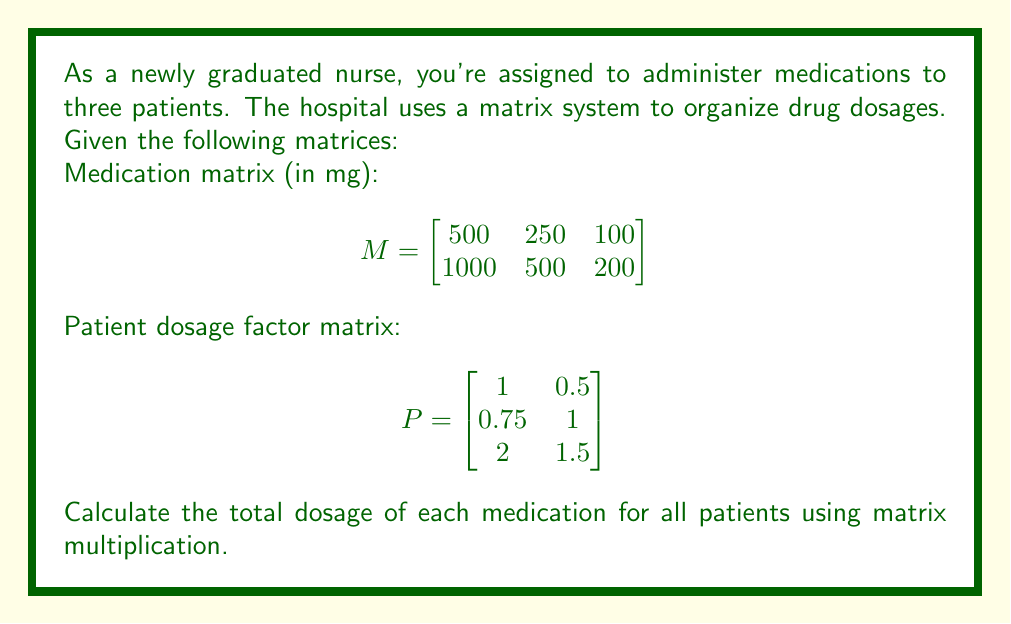Give your solution to this math problem. To solve this problem, we need to multiply the medication matrix (M) by the patient dosage factor matrix (P). The resulting matrix will give us the total dosage of each medication for all patients.

Step 1: Set up the matrix multiplication
$$M \times P = \begin{bmatrix}
500 & 250 & 100 \\
1000 & 500 & 200
\end{bmatrix} \times \begin{bmatrix}
1 & 0.5 \\
0.75 & 1 \\
2 & 1.5
\end{bmatrix}$$

Step 2: Perform the matrix multiplication
For each element in the resulting matrix, we multiply the corresponding row of M with the corresponding column of P and sum the results.

Element (1,1):
$(500 \times 1) + (250 \times 0.75) + (100 \times 2) = 500 + 187.5 + 200 = 887.5$

Element (1,2):
$(500 \times 0.5) + (250 \times 1) + (100 \times 1.5) = 250 + 250 + 150 = 650$

Element (2,1):
$(1000 \times 1) + (500 \times 0.75) + (200 \times 2) = 1000 + 375 + 400 = 1775$

Element (2,2):
$(1000 \times 0.5) + (500 \times 1) + (200 \times 1.5) = 500 + 500 + 300 = 1300$

Step 3: Write the resulting matrix
$$\begin{bmatrix}
887.5 & 650 \\
1775 & 1300
\end{bmatrix}$$

This matrix represents the total dosage of each medication for all patients. The first row corresponds to the first medication, and the second row corresponds to the second medication. The columns represent the total dosage for each patient group.
Answer: $$\begin{bmatrix}
887.5 & 650 \\
1775 & 1300
\end{bmatrix}$$ 